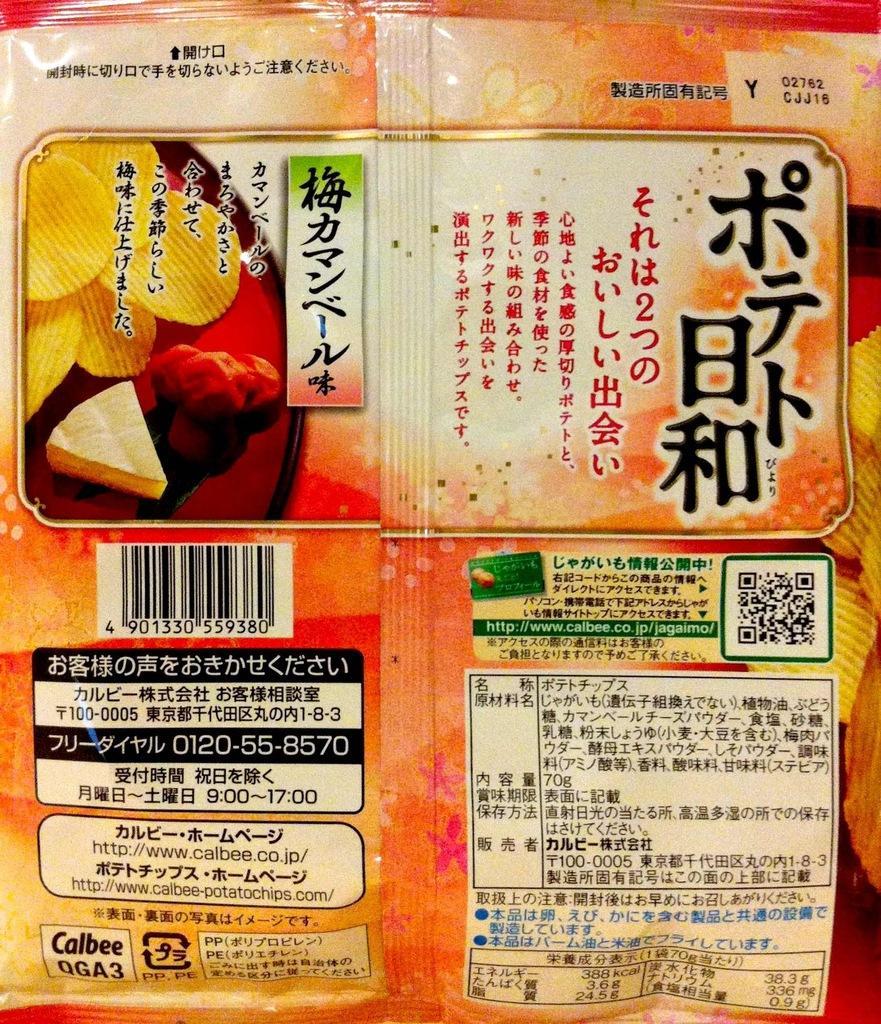Could you give a brief overview of what you see in this image? In the center of the image there is a cover. 